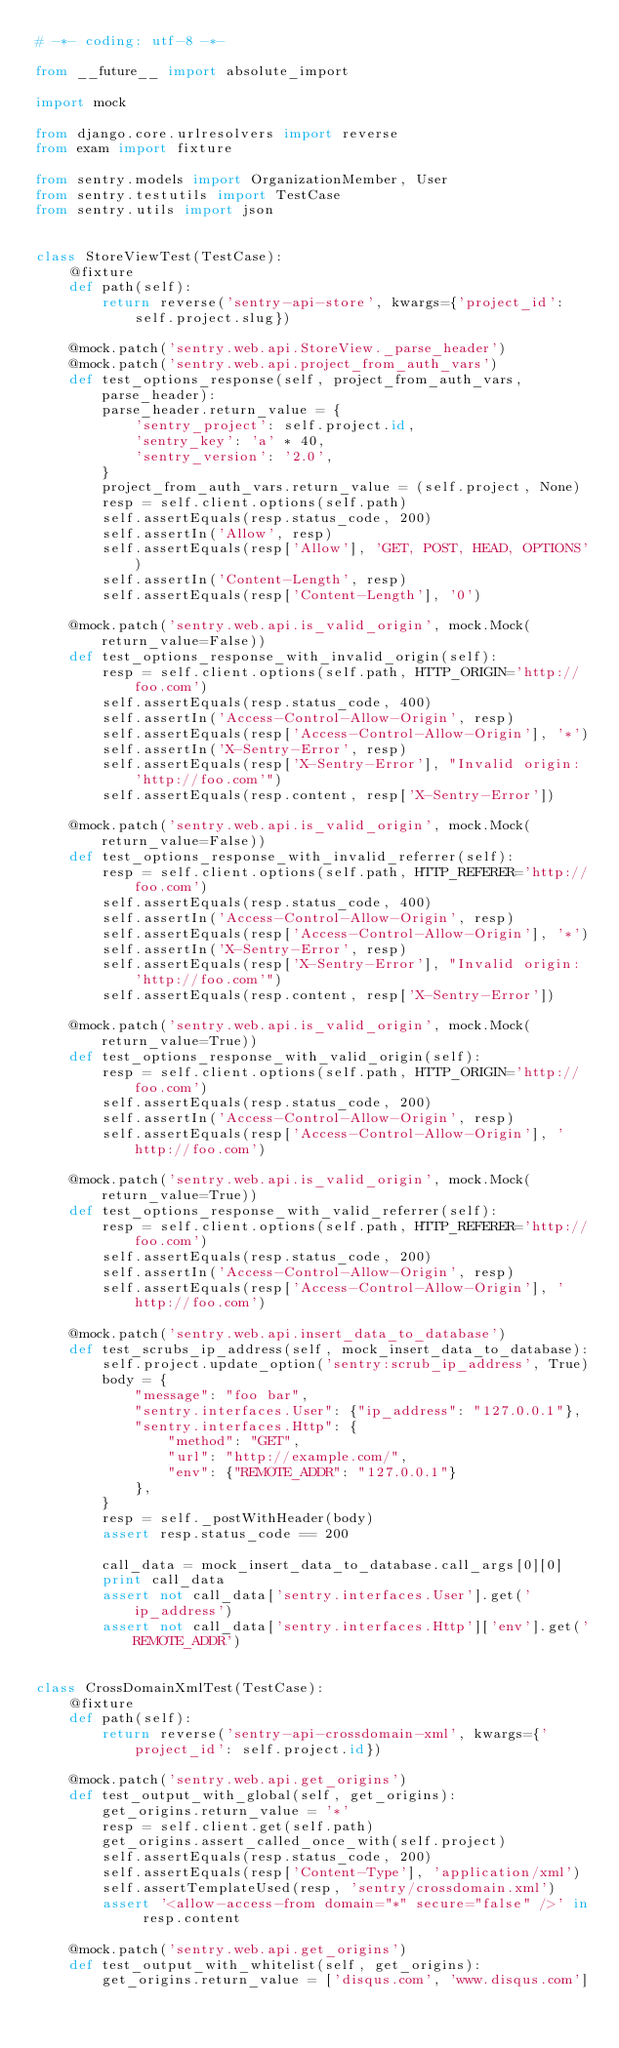<code> <loc_0><loc_0><loc_500><loc_500><_Python_># -*- coding: utf-8 -*-

from __future__ import absolute_import

import mock

from django.core.urlresolvers import reverse
from exam import fixture

from sentry.models import OrganizationMember, User
from sentry.testutils import TestCase
from sentry.utils import json


class StoreViewTest(TestCase):
    @fixture
    def path(self):
        return reverse('sentry-api-store', kwargs={'project_id': self.project.slug})

    @mock.patch('sentry.web.api.StoreView._parse_header')
    @mock.patch('sentry.web.api.project_from_auth_vars')
    def test_options_response(self, project_from_auth_vars, parse_header):
        parse_header.return_value = {
            'sentry_project': self.project.id,
            'sentry_key': 'a' * 40,
            'sentry_version': '2.0',
        }
        project_from_auth_vars.return_value = (self.project, None)
        resp = self.client.options(self.path)
        self.assertEquals(resp.status_code, 200)
        self.assertIn('Allow', resp)
        self.assertEquals(resp['Allow'], 'GET, POST, HEAD, OPTIONS')
        self.assertIn('Content-Length', resp)
        self.assertEquals(resp['Content-Length'], '0')

    @mock.patch('sentry.web.api.is_valid_origin', mock.Mock(return_value=False))
    def test_options_response_with_invalid_origin(self):
        resp = self.client.options(self.path, HTTP_ORIGIN='http://foo.com')
        self.assertEquals(resp.status_code, 400)
        self.assertIn('Access-Control-Allow-Origin', resp)
        self.assertEquals(resp['Access-Control-Allow-Origin'], '*')
        self.assertIn('X-Sentry-Error', resp)
        self.assertEquals(resp['X-Sentry-Error'], "Invalid origin: 'http://foo.com'")
        self.assertEquals(resp.content, resp['X-Sentry-Error'])

    @mock.patch('sentry.web.api.is_valid_origin', mock.Mock(return_value=False))
    def test_options_response_with_invalid_referrer(self):
        resp = self.client.options(self.path, HTTP_REFERER='http://foo.com')
        self.assertEquals(resp.status_code, 400)
        self.assertIn('Access-Control-Allow-Origin', resp)
        self.assertEquals(resp['Access-Control-Allow-Origin'], '*')
        self.assertIn('X-Sentry-Error', resp)
        self.assertEquals(resp['X-Sentry-Error'], "Invalid origin: 'http://foo.com'")
        self.assertEquals(resp.content, resp['X-Sentry-Error'])

    @mock.patch('sentry.web.api.is_valid_origin', mock.Mock(return_value=True))
    def test_options_response_with_valid_origin(self):
        resp = self.client.options(self.path, HTTP_ORIGIN='http://foo.com')
        self.assertEquals(resp.status_code, 200)
        self.assertIn('Access-Control-Allow-Origin', resp)
        self.assertEquals(resp['Access-Control-Allow-Origin'], 'http://foo.com')

    @mock.patch('sentry.web.api.is_valid_origin', mock.Mock(return_value=True))
    def test_options_response_with_valid_referrer(self):
        resp = self.client.options(self.path, HTTP_REFERER='http://foo.com')
        self.assertEquals(resp.status_code, 200)
        self.assertIn('Access-Control-Allow-Origin', resp)
        self.assertEquals(resp['Access-Control-Allow-Origin'], 'http://foo.com')

    @mock.patch('sentry.web.api.insert_data_to_database')
    def test_scrubs_ip_address(self, mock_insert_data_to_database):
        self.project.update_option('sentry:scrub_ip_address', True)
        body = {
            "message": "foo bar",
            "sentry.interfaces.User": {"ip_address": "127.0.0.1"},
            "sentry.interfaces.Http": {
                "method": "GET",
                "url": "http://example.com/",
                "env": {"REMOTE_ADDR": "127.0.0.1"}
            },
        }
        resp = self._postWithHeader(body)
        assert resp.status_code == 200

        call_data = mock_insert_data_to_database.call_args[0][0]
        print call_data
        assert not call_data['sentry.interfaces.User'].get('ip_address')
        assert not call_data['sentry.interfaces.Http']['env'].get('REMOTE_ADDR')


class CrossDomainXmlTest(TestCase):
    @fixture
    def path(self):
        return reverse('sentry-api-crossdomain-xml', kwargs={'project_id': self.project.id})

    @mock.patch('sentry.web.api.get_origins')
    def test_output_with_global(self, get_origins):
        get_origins.return_value = '*'
        resp = self.client.get(self.path)
        get_origins.assert_called_once_with(self.project)
        self.assertEquals(resp.status_code, 200)
        self.assertEquals(resp['Content-Type'], 'application/xml')
        self.assertTemplateUsed(resp, 'sentry/crossdomain.xml')
        assert '<allow-access-from domain="*" secure="false" />' in resp.content

    @mock.patch('sentry.web.api.get_origins')
    def test_output_with_whitelist(self, get_origins):
        get_origins.return_value = ['disqus.com', 'www.disqus.com']</code> 